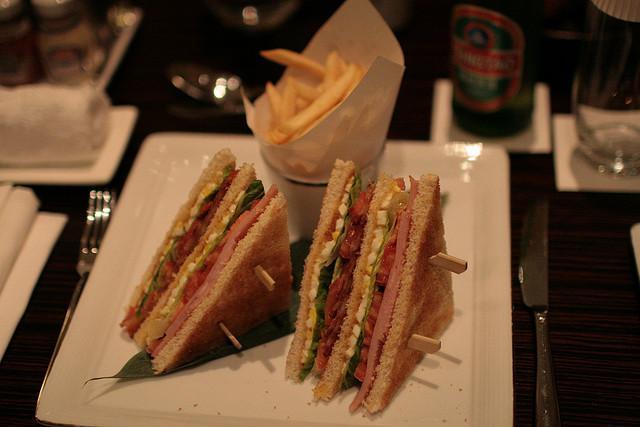How many bottles are there?
Give a very brief answer. 3. How many sandwiches can you see?
Give a very brief answer. 2. 